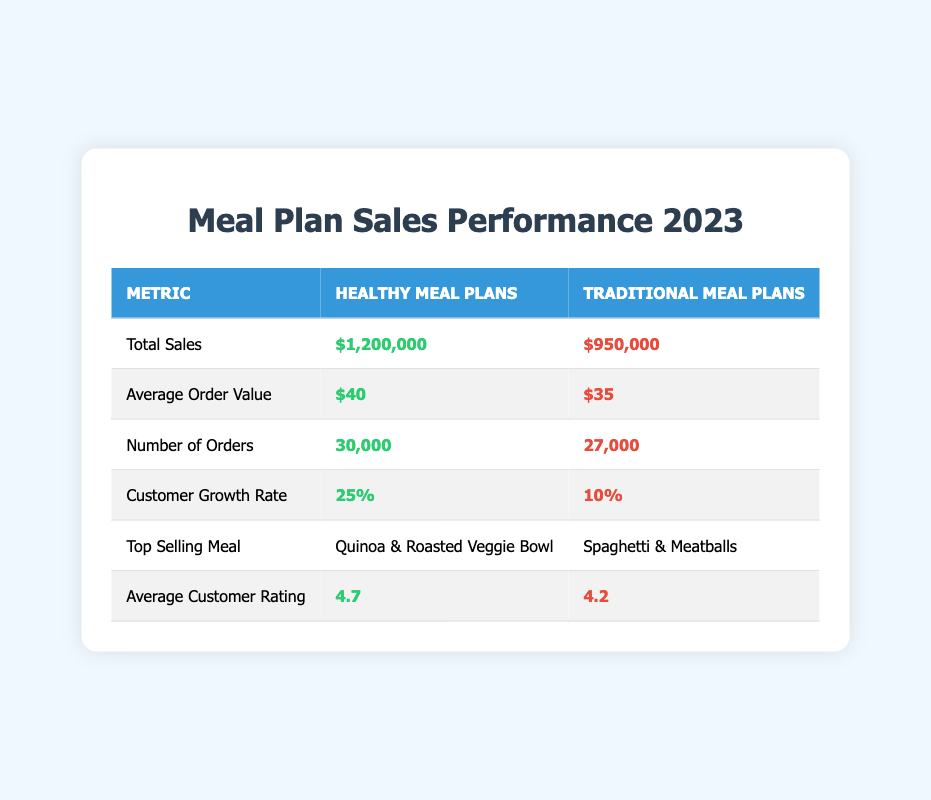What is the total sales amount for Healthy Meal Plans? The total sales for Healthy Meal Plans is explicitly mentioned in the table under "Total Sales" for that category. It shows $1,200,000.
Answer: $1,200,000 How many orders were placed for Traditional Meal Plans? The total number of orders for Traditional Meal Plans is stated in the table under "Number of Orders." It shows 27,000 orders.
Answer: 27,000 What is the average customer rating for Healthy Meal Plans? The average customer rating for Healthy Meal Plans is listed in the table under "Average Customer Rating." It shows a rating of 4.7.
Answer: 4.7 By how much did the customer growth rate for Healthy Meal Plans exceed that of Traditional Meal Plans? The customer growth rate for Healthy Meal Plans is 25%, and for Traditional Meal Plans, it is 10%. To find the difference: 25% - 10% = 15%.
Answer: 15% Is the top selling meal for Healthy Meal Plans a pasta dish? The top selling meal for Healthy Meal Plans is "Quinoa & Roasted Veggie Bowl," which is not a pasta dish. Therefore, the answer is no.
Answer: No Which meal plan had a higher average order value, and by how much? Healthy Meal Plans have an average order value of $40, while Traditional Meal Plans have an average order value of $35. The difference is $40 - $35 = $5, indicating Healthy Meal Plans had a higher average order value.
Answer: $5 Do Traditional Meal Plans have a higher average customer rating than Healthy Meal Plans? The average customer rating for Traditional Meal Plans is 4.2 while that for Healthy Meal Plans is 4.7. This means that Traditional Meal Plans do not have a higher rating. Therefore, the answer is no.
Answer: No What percentage of total sales does Healthy Meal Plans represent compared to Traditional Meal Plans? To find the percentage, we first calculate total sales: $1,200,000 (Healthy) + $950,000 (Traditional) = $2,150,000. Then, the percentage for Healthy Meal Plans is ($1,200,000 / $2,150,000) x 100% ≈ 55.81%.
Answer: 55.81% How does the number of orders for Healthy Meal Plans compare to that for Traditional Meal Plans? The number of orders for Healthy Meal Plans is 30,000 while for Traditional Meal Plans it is 27,000. Healthy Meal Plans have more orders since 30,000 > 27,000. Thus, the answer is yes, Healthy Meal Plans have more orders.
Answer: Yes 